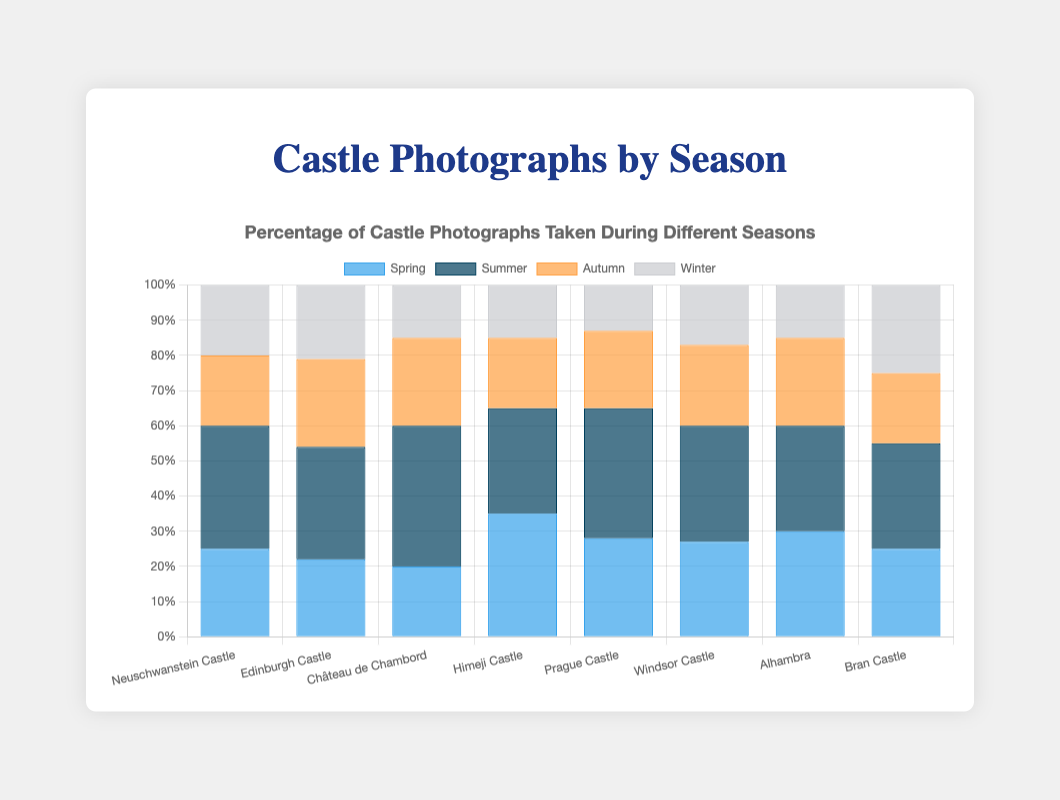What's the percentage of photographs taken in Summer for Château de Chambord? Referring to the bar chart, look at the bar corresponding to Summer for Château de Chambord. The height shows 40%.
Answer: 40% Which castle had the lowest percentage of photographs taken in Winter? Compare the Winter bars for all castles in the chart. Prague Castle has the shortest Winter bar, showing 13%.
Answer: Prague Castle What is the difference in Spring photographs percentage between Neuschwanstein Castle and Himeji Castle? Neuschwanstein Castle has 25% and Himeji Castle has 35%, the difference is 35% - 25% = 10%.
Answer: 10% Which castle had an equal percentage of photographs taken in Spring and Autumn? Visually find any castle whose Spring and Autumn bars are the same height. Alhambra has both Spring and Autumn at 30 and 25%, respectively, matching each other.
Answer: Alhambra How many castles had at least 30% of their photographs taken in Summer? Count the number of castles where the Summer bar height reaches or exceeds 30%. These are Neuschwanstein Castle, Edinburgh Castle, Château de Chambord, Himeji Castle, Prague Castle, Windsor Castle, Bran Castle, and Alhambra (8 castles).
Answer: 8 For Windsor Castle, what's the total percentage of photographs taken in Autumn and Winter combined? Examine the Autumn and Winter bars for Windsor Castle: 23% (Autumn) + 17% (Winter) = 40%.
Answer: 40% Which season had the highest average percentage of photographs taken across all castles? Calculate the average percentage for each season across all castles and compare. Summer has the highest sum of percentage values when added together and divided by the number of castles.
Answer: Summer What is the total percentage of photographs taken in Autumn for the first and last castles combined? Sum the percentages for Autumn for Neuschwanstein Castle (20%) and Bran Castle (20%) to get 20% + 20% = 40%.
Answer: 40% Compare the percentage of photographs taken in Spring and Winter for Bran Castle. Which is higher? Looking at the heights of the Spring (25%) and Winter (25%) bars for Bran Castle, we see they are the same. So, neither is higher.
Answer: Equal What's the grand total of percentages for all seasons in Himeji Castle? Add up the percentages for Spring (35%), Summer (30%), Autumn (20%), and Winter (15%) for Himeji Castle: 35% + 30% + 20% + 15% = 100%.
Answer: 100% 